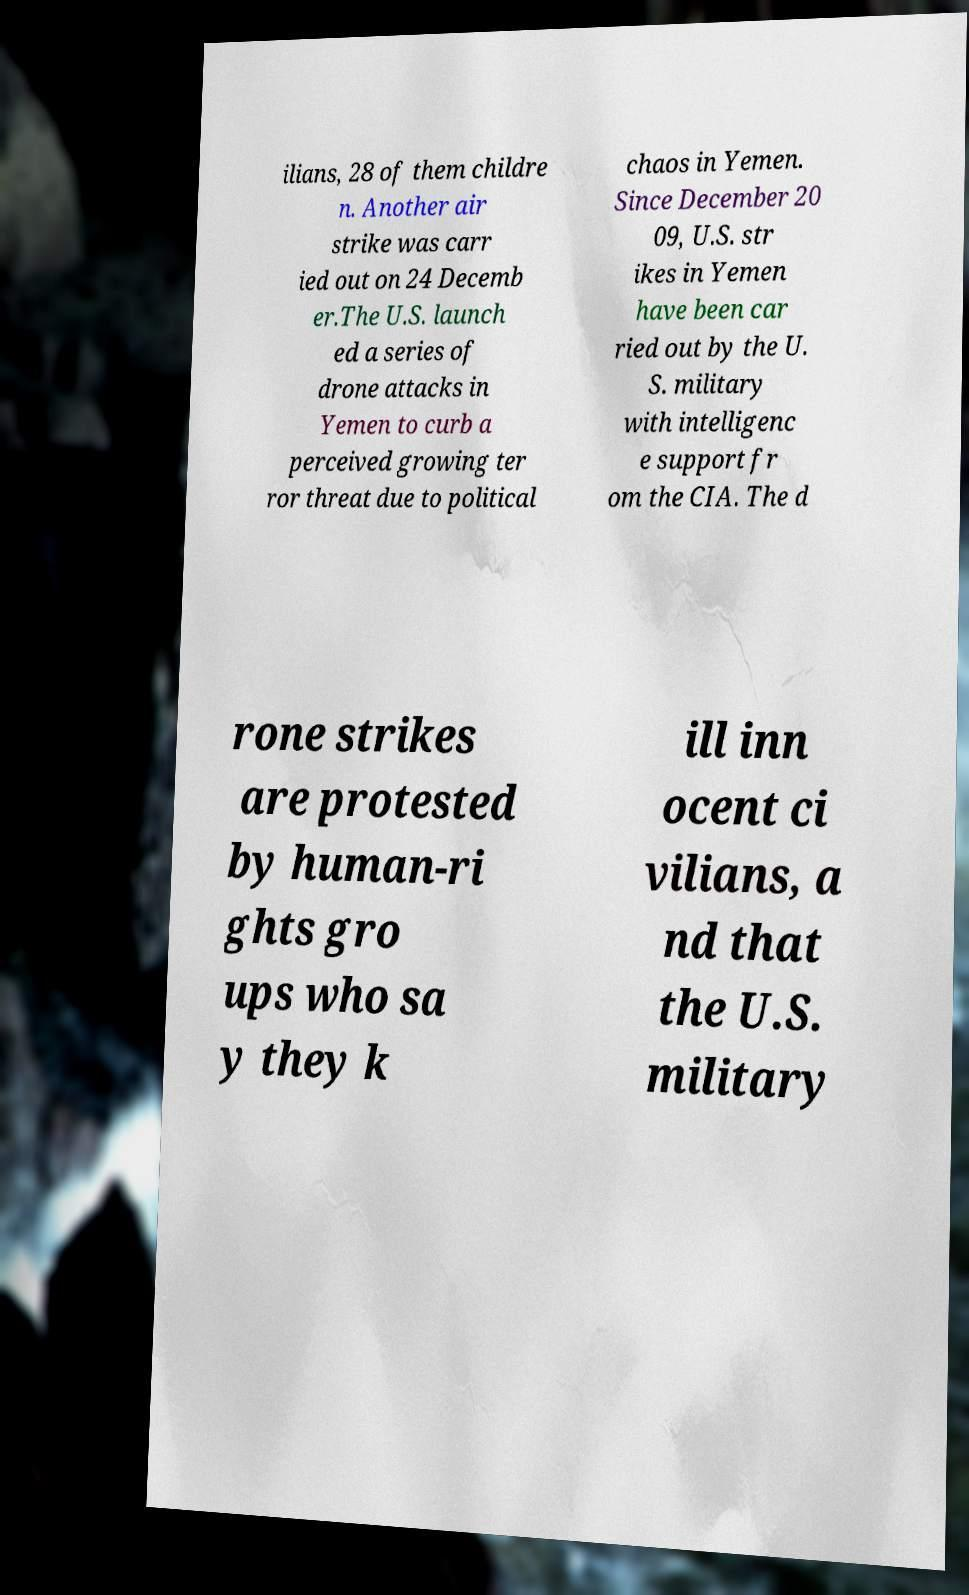Can you read and provide the text displayed in the image?This photo seems to have some interesting text. Can you extract and type it out for me? ilians, 28 of them childre n. Another air strike was carr ied out on 24 Decemb er.The U.S. launch ed a series of drone attacks in Yemen to curb a perceived growing ter ror threat due to political chaos in Yemen. Since December 20 09, U.S. str ikes in Yemen have been car ried out by the U. S. military with intelligenc e support fr om the CIA. The d rone strikes are protested by human-ri ghts gro ups who sa y they k ill inn ocent ci vilians, a nd that the U.S. military 